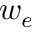<formula> <loc_0><loc_0><loc_500><loc_500>w _ { e }</formula> 